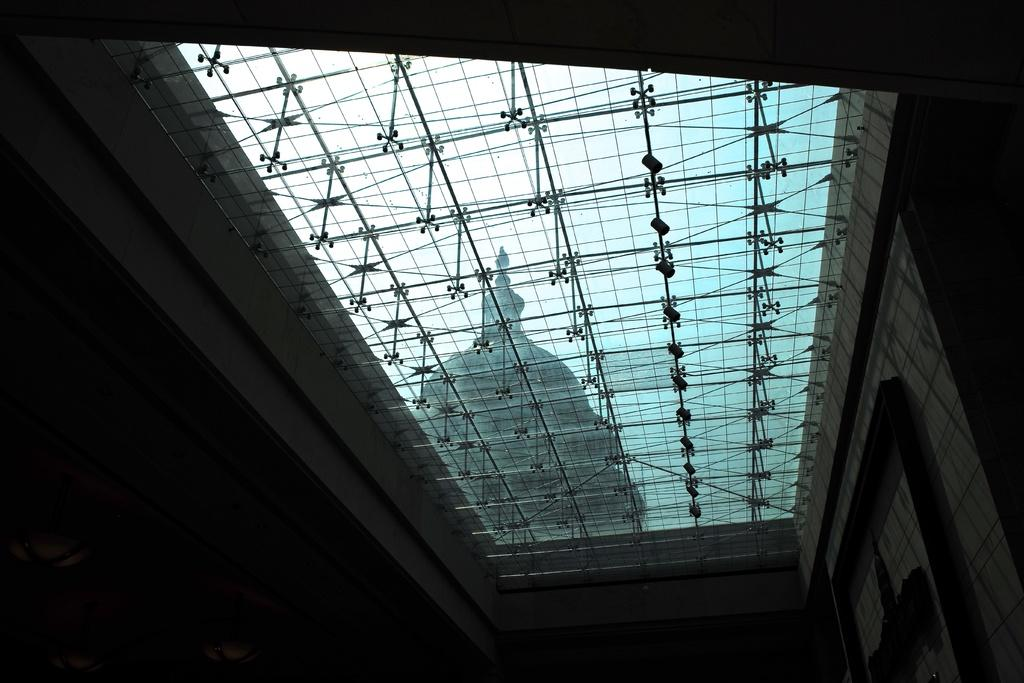What type of view is shown in the image? The image shows an inside view of a building. What can be seen in the background of the image? The background includes the sky and other objects. Can you describe the sky in the image? The sky is visible in the background of the image. What type of cherry is being heard in the image? There is no cherry present in the image, and therefore no sound can be heard from it. In which bedroom is the image taken? The image does not show a bedroom; it shows an inside view of a building. 